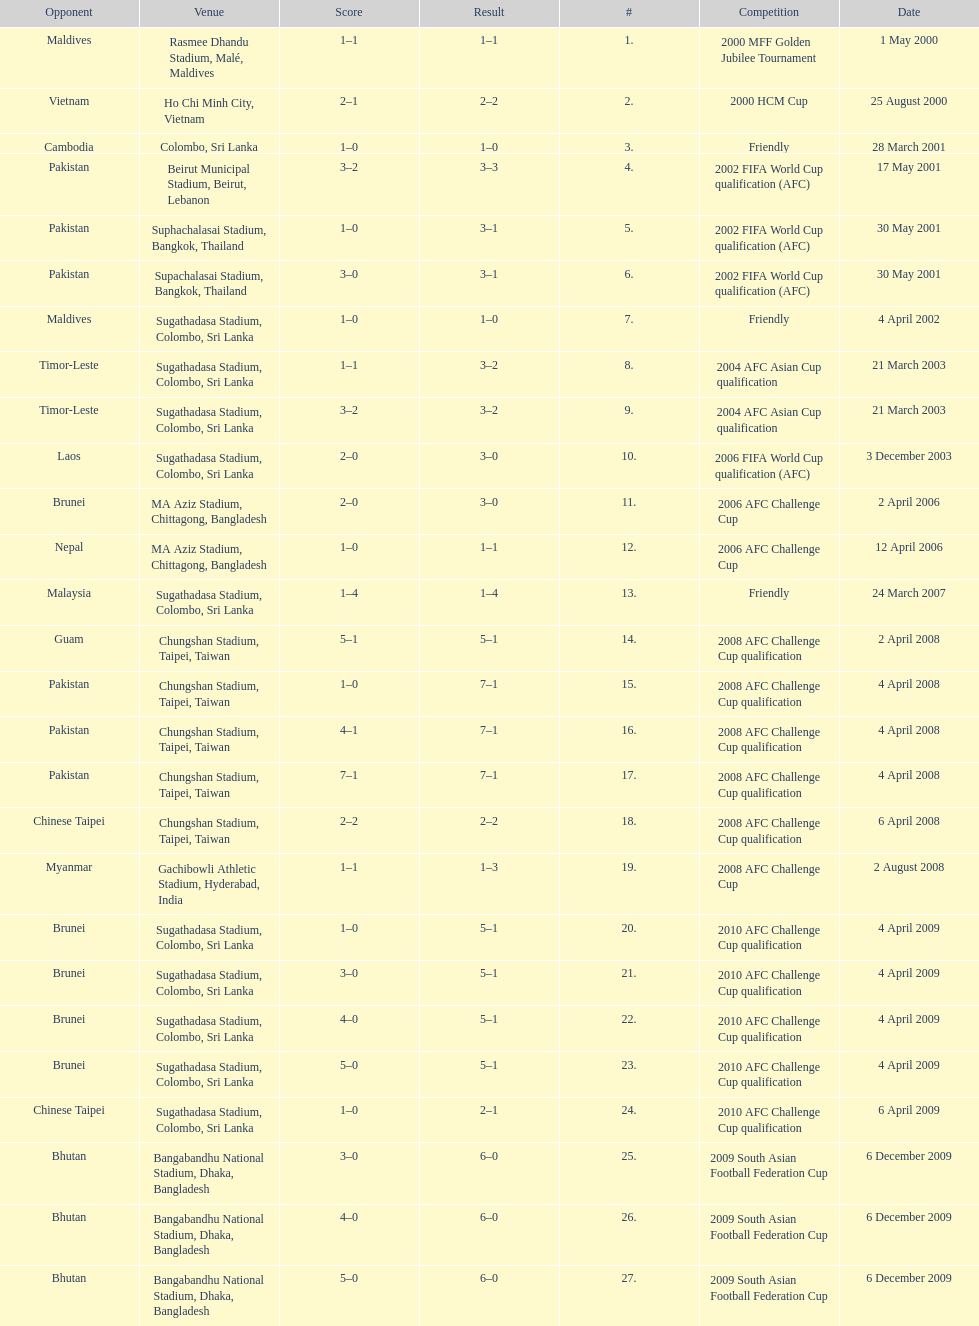Were more competitions played in april or december? April. 